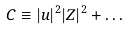Convert formula to latex. <formula><loc_0><loc_0><loc_500><loc_500>C \equiv | u | ^ { 2 } | Z | ^ { 2 } + \dots</formula> 